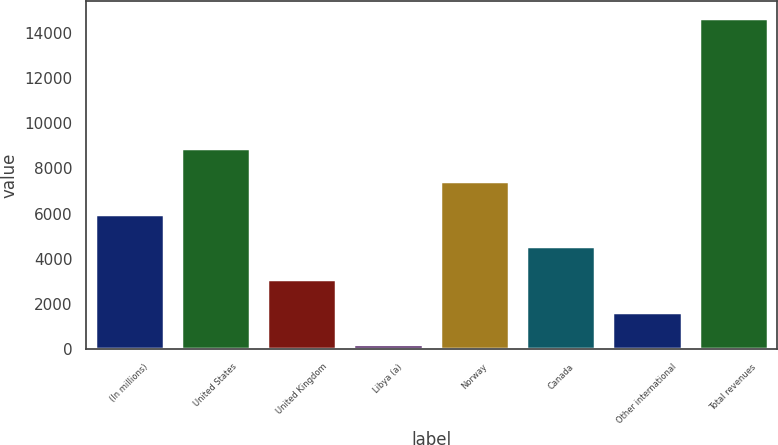<chart> <loc_0><loc_0><loc_500><loc_500><bar_chart><fcel>(In millions)<fcel>United States<fcel>United Kingdom<fcel>Libya (a)<fcel>Norway<fcel>Canada<fcel>Other international<fcel>Total revenues<nl><fcel>5994.8<fcel>8884.2<fcel>3105.4<fcel>216<fcel>7439.5<fcel>4550.1<fcel>1660.7<fcel>14663<nl></chart> 